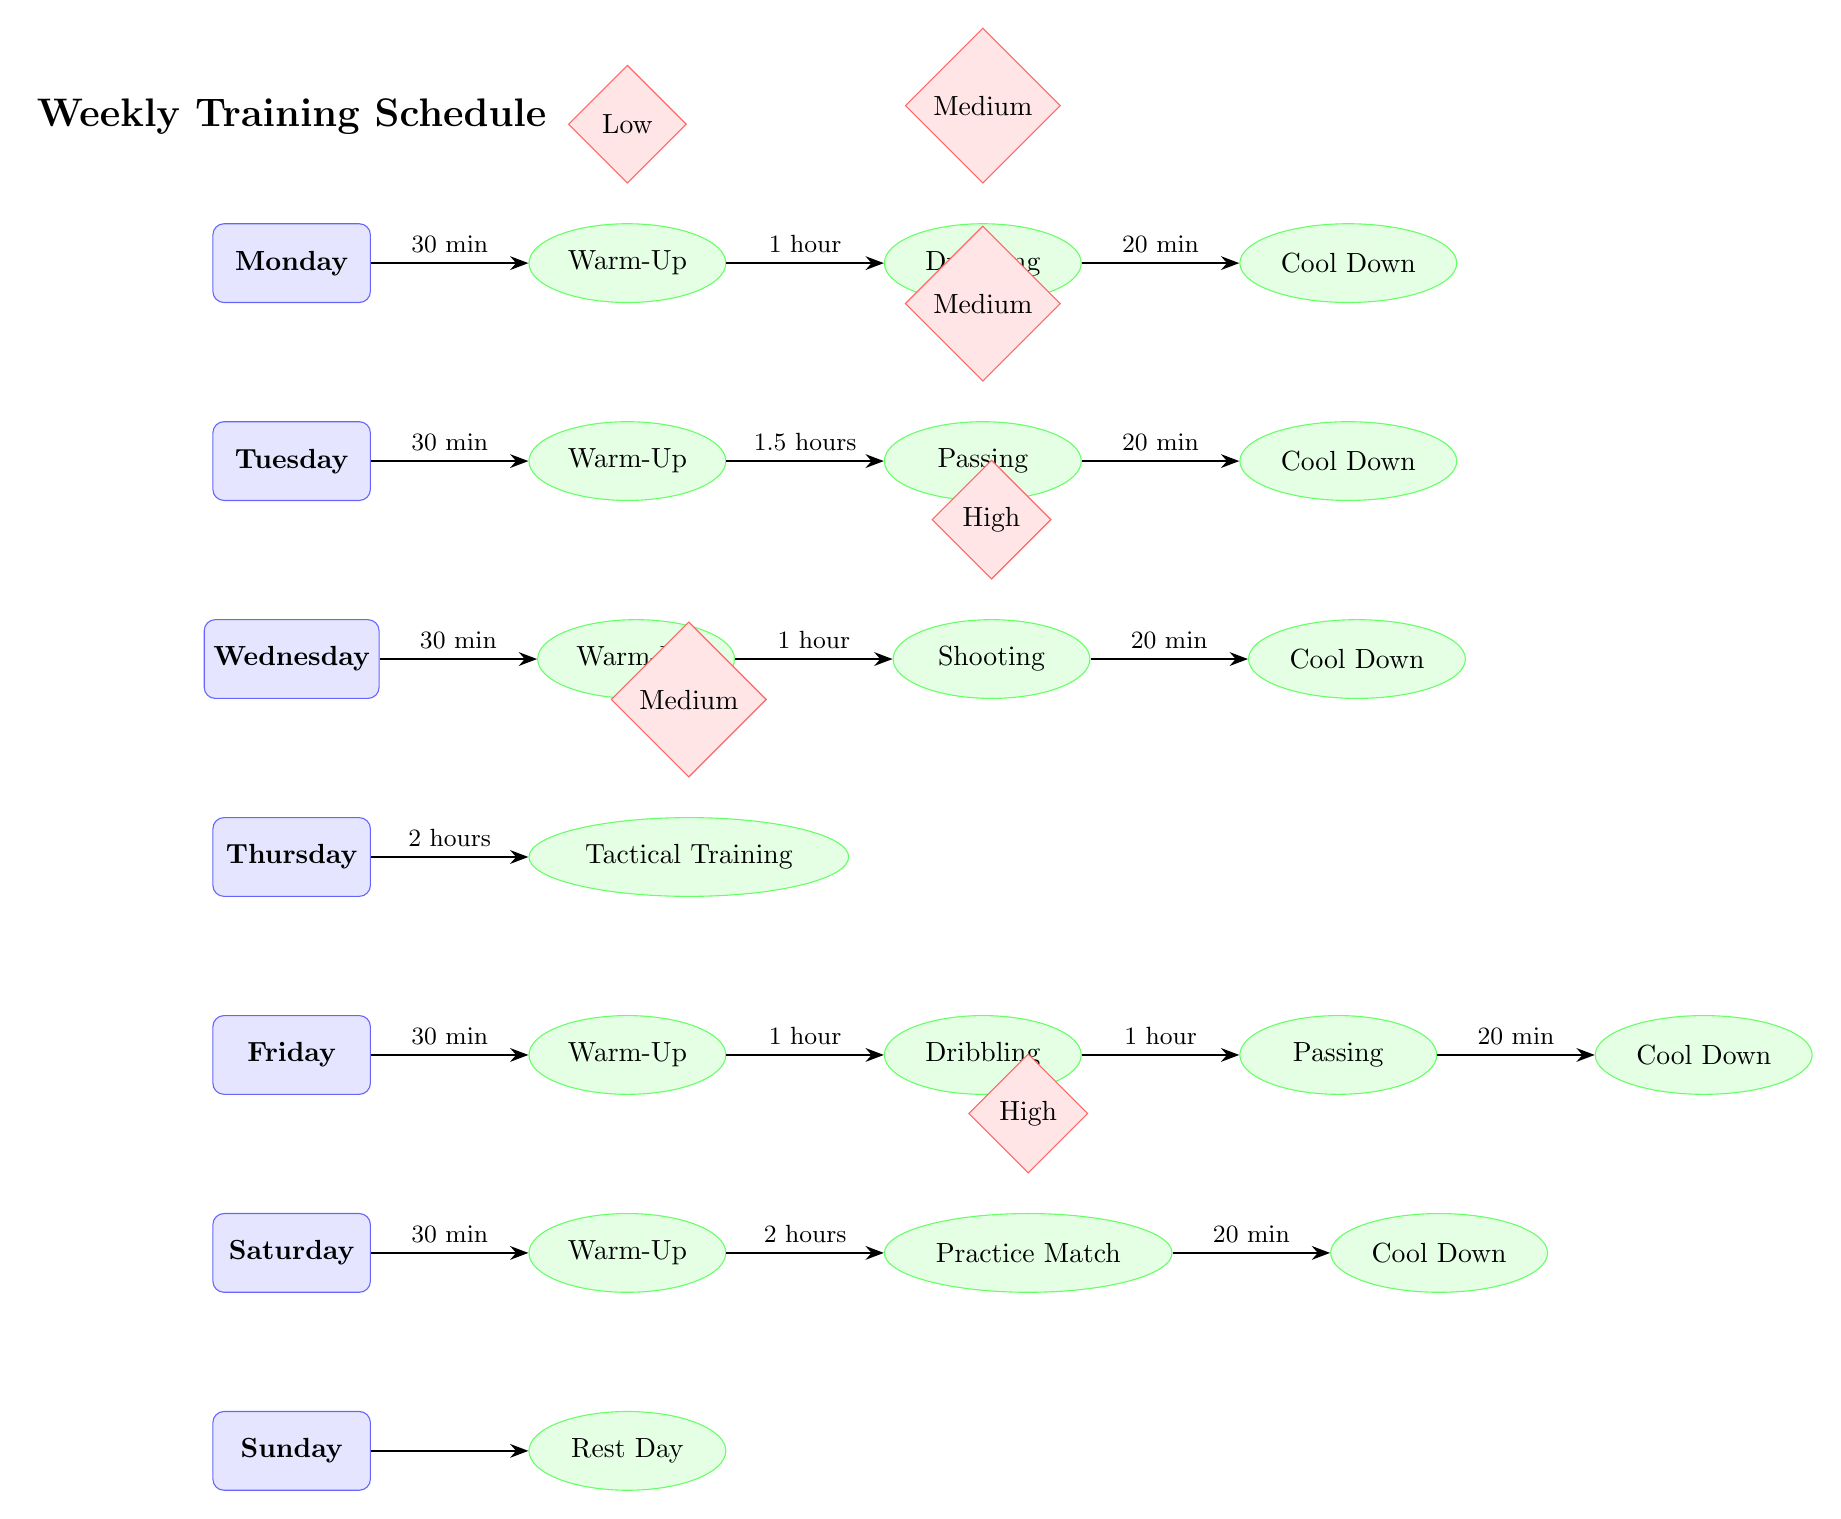What's the total time for Monday's training session? The diagram shows three training activities for Monday: Warm-Up (30 min), Dribbling (1 hour), and Cool Down (20 min). To find the total time, we can sum the durations: 30 min + 60 min + 20 min = 110 min.
Answer: 110 min Which day has Tactical Training? Looking at the diagram, Tactical Training appears on Thursday. It is listed as the only activity for that day.
Answer: Thursday What is the intensity level of the Practice Match on Saturday? The diagram indicates the intensity level above the Practice Match activity on Saturday, which is marked as High.
Answer: High How many warm-up sessions are scheduled throughout the week? By inspecting the diagram, we see that there is a Warm-Up session every day from Monday to Saturday, except for Sunday, which totals to six warm-up sessions.
Answer: 6 What is the duration of the Passing activity on Tuesday? In the diagram, the duration for Passing on Tuesday is specified as 1.5 hours.
Answer: 1.5 hours Which training session lasts the longest duration? By analyzing the diagram, the Practice Match on Saturday lasts for 2 hours, which is longer than all other training sessions throughout the week.
Answer: 2 hours What is the total training time on Friday? The training activities on Friday are Warm-Up (30 min), Dribbling (1 hour), Passing (1 hour), and Cool Down (20 min). Adding these gives: 30 min + 60 min + 60 min + 20 min = 170 min.
Answer: 170 min On which day is the rest day? The diagram clearly indicates that Sunday is designated as the Rest Day, with no activities assigned.
Answer: Sunday 